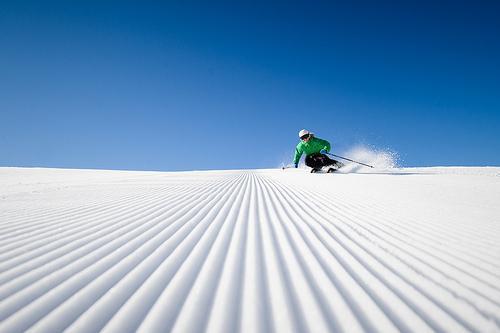How many women are there?
Give a very brief answer. 1. 